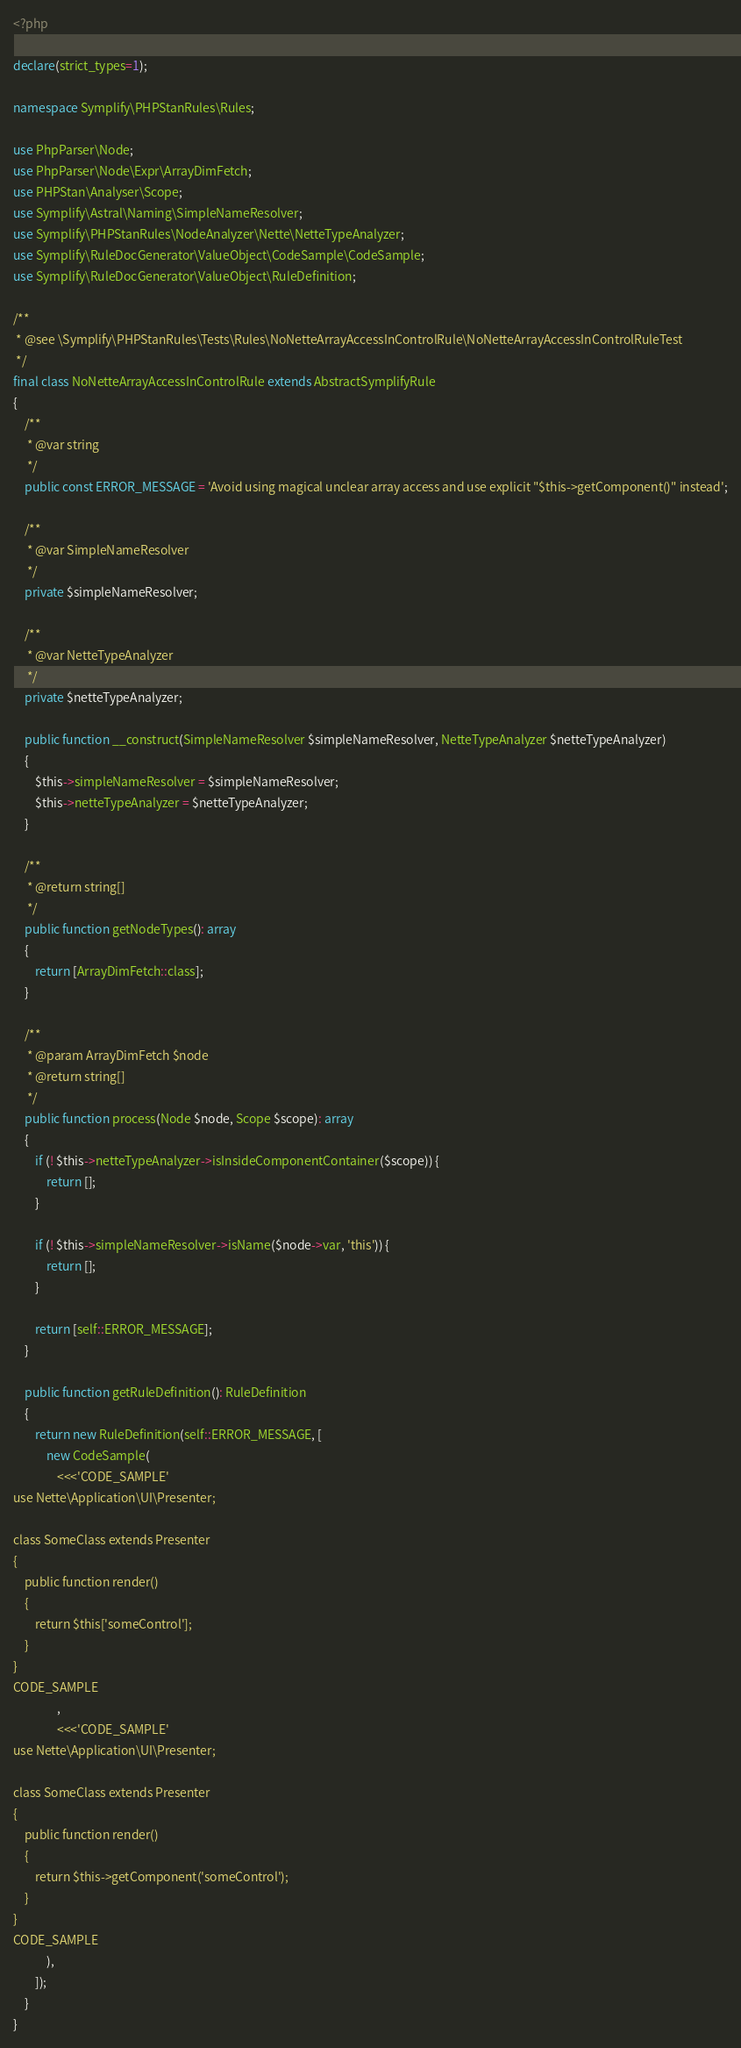<code> <loc_0><loc_0><loc_500><loc_500><_PHP_><?php

declare(strict_types=1);

namespace Symplify\PHPStanRules\Rules;

use PhpParser\Node;
use PhpParser\Node\Expr\ArrayDimFetch;
use PHPStan\Analyser\Scope;
use Symplify\Astral\Naming\SimpleNameResolver;
use Symplify\PHPStanRules\NodeAnalyzer\Nette\NetteTypeAnalyzer;
use Symplify\RuleDocGenerator\ValueObject\CodeSample\CodeSample;
use Symplify\RuleDocGenerator\ValueObject\RuleDefinition;

/**
 * @see \Symplify\PHPStanRules\Tests\Rules\NoNetteArrayAccessInControlRule\NoNetteArrayAccessInControlRuleTest
 */
final class NoNetteArrayAccessInControlRule extends AbstractSymplifyRule
{
    /**
     * @var string
     */
    public const ERROR_MESSAGE = 'Avoid using magical unclear array access and use explicit "$this->getComponent()" instead';

    /**
     * @var SimpleNameResolver
     */
    private $simpleNameResolver;

    /**
     * @var NetteTypeAnalyzer
     */
    private $netteTypeAnalyzer;

    public function __construct(SimpleNameResolver $simpleNameResolver, NetteTypeAnalyzer $netteTypeAnalyzer)
    {
        $this->simpleNameResolver = $simpleNameResolver;
        $this->netteTypeAnalyzer = $netteTypeAnalyzer;
    }

    /**
     * @return string[]
     */
    public function getNodeTypes(): array
    {
        return [ArrayDimFetch::class];
    }

    /**
     * @param ArrayDimFetch $node
     * @return string[]
     */
    public function process(Node $node, Scope $scope): array
    {
        if (! $this->netteTypeAnalyzer->isInsideComponentContainer($scope)) {
            return [];
        }

        if (! $this->simpleNameResolver->isName($node->var, 'this')) {
            return [];
        }

        return [self::ERROR_MESSAGE];
    }

    public function getRuleDefinition(): RuleDefinition
    {
        return new RuleDefinition(self::ERROR_MESSAGE, [
            new CodeSample(
                <<<'CODE_SAMPLE'
use Nette\Application\UI\Presenter;

class SomeClass extends Presenter
{
    public function render()
    {
        return $this['someControl'];
    }
}
CODE_SAMPLE
                ,
                <<<'CODE_SAMPLE'
use Nette\Application\UI\Presenter;

class SomeClass extends Presenter
{
    public function render()
    {
        return $this->getComponent('someControl');
    }
}
CODE_SAMPLE
            ),
        ]);
    }
}
</code> 